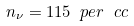<formula> <loc_0><loc_0><loc_500><loc_500>n _ { \nu } = 1 1 5 \ p e r \ c c</formula> 